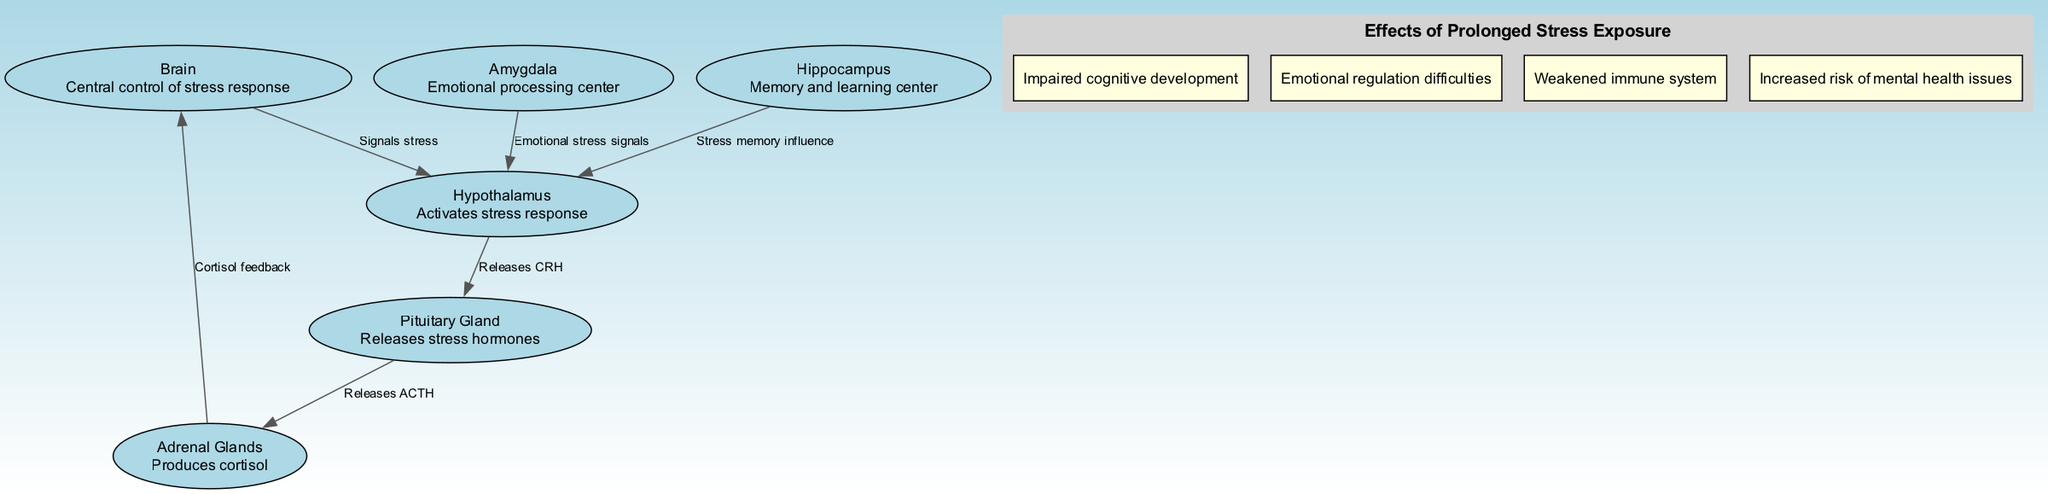What is the main control center for the stress response? The diagram indicates that the brain is the central control of the stress response. This is evident as it is the node labeled "Brain" with the description defining it as the central control.
Answer: Brain How many nodes are present in the diagram? Counting the nodes listed in the diagram shows there are six distinct nodes: Brain, Hypothalamus, Pituitary Gland, Adrenal Glands, Amygdala, and Hippocampus.
Answer: Six What does the amygdala signal to the hypothalamus? The diagram states that the amygdala sends emotional stress signals to the hypothalamus. This is reflected in the directed edge connecting these two nodes labeled "Emotional stress signals."
Answer: Emotional stress signals Which hormone is released by the pituitary gland? According to the diagram, the pituitary gland releases ACTH, as indicated by the edge labeled "Releases ACTH" connecting the pituitary to the adrenal glands.
Answer: ACTH What are the effects of prolonged stress exposure mentioned in the diagram? The diagram enumerates various effects in a cluster, including impaired cognitive development, emotional regulation difficulties, weakened immune system, and increased risk of mental health issues. Therefore, they collectively describe the consequences of prolonged stress.
Answer: Impaired cognitive development, emotional regulation difficulties, weakened immune system, increased risk of mental health issues How does cortisol influence the brain? The diagram indicates that the adrenal glands produce cortisol which then provides feedback to the brain. This is shown in the edge labeled "Cortisol feedback" flowing back to the brain from the adrenal glands, illustrating the regulatory role of cortisol.
Answer: Cortisol feedback What role does the hippocampus play in the stress response? The hippocampus influences the hypothalamus regarding stress memory, as depicted in the directed edge marked "Stress memory influence." This indicates that stress memories created by the hippocampus impact the activation of the stress response by the hypothalamus.
Answer: Stress memory influence Which part of the stress response system is responsible for emotional processing? The diagram identifies the amygdala as the emotional processing center in its description. It serves as a critical node for processing emotional responses linked to stress.
Answer: Amygdala 